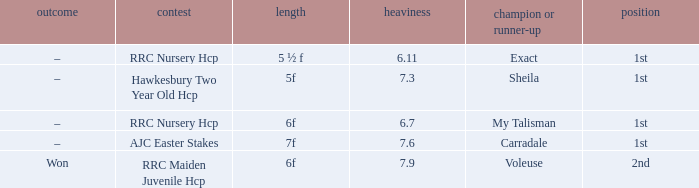What was the distance when the weight was 6.11? 5 ½ f. 